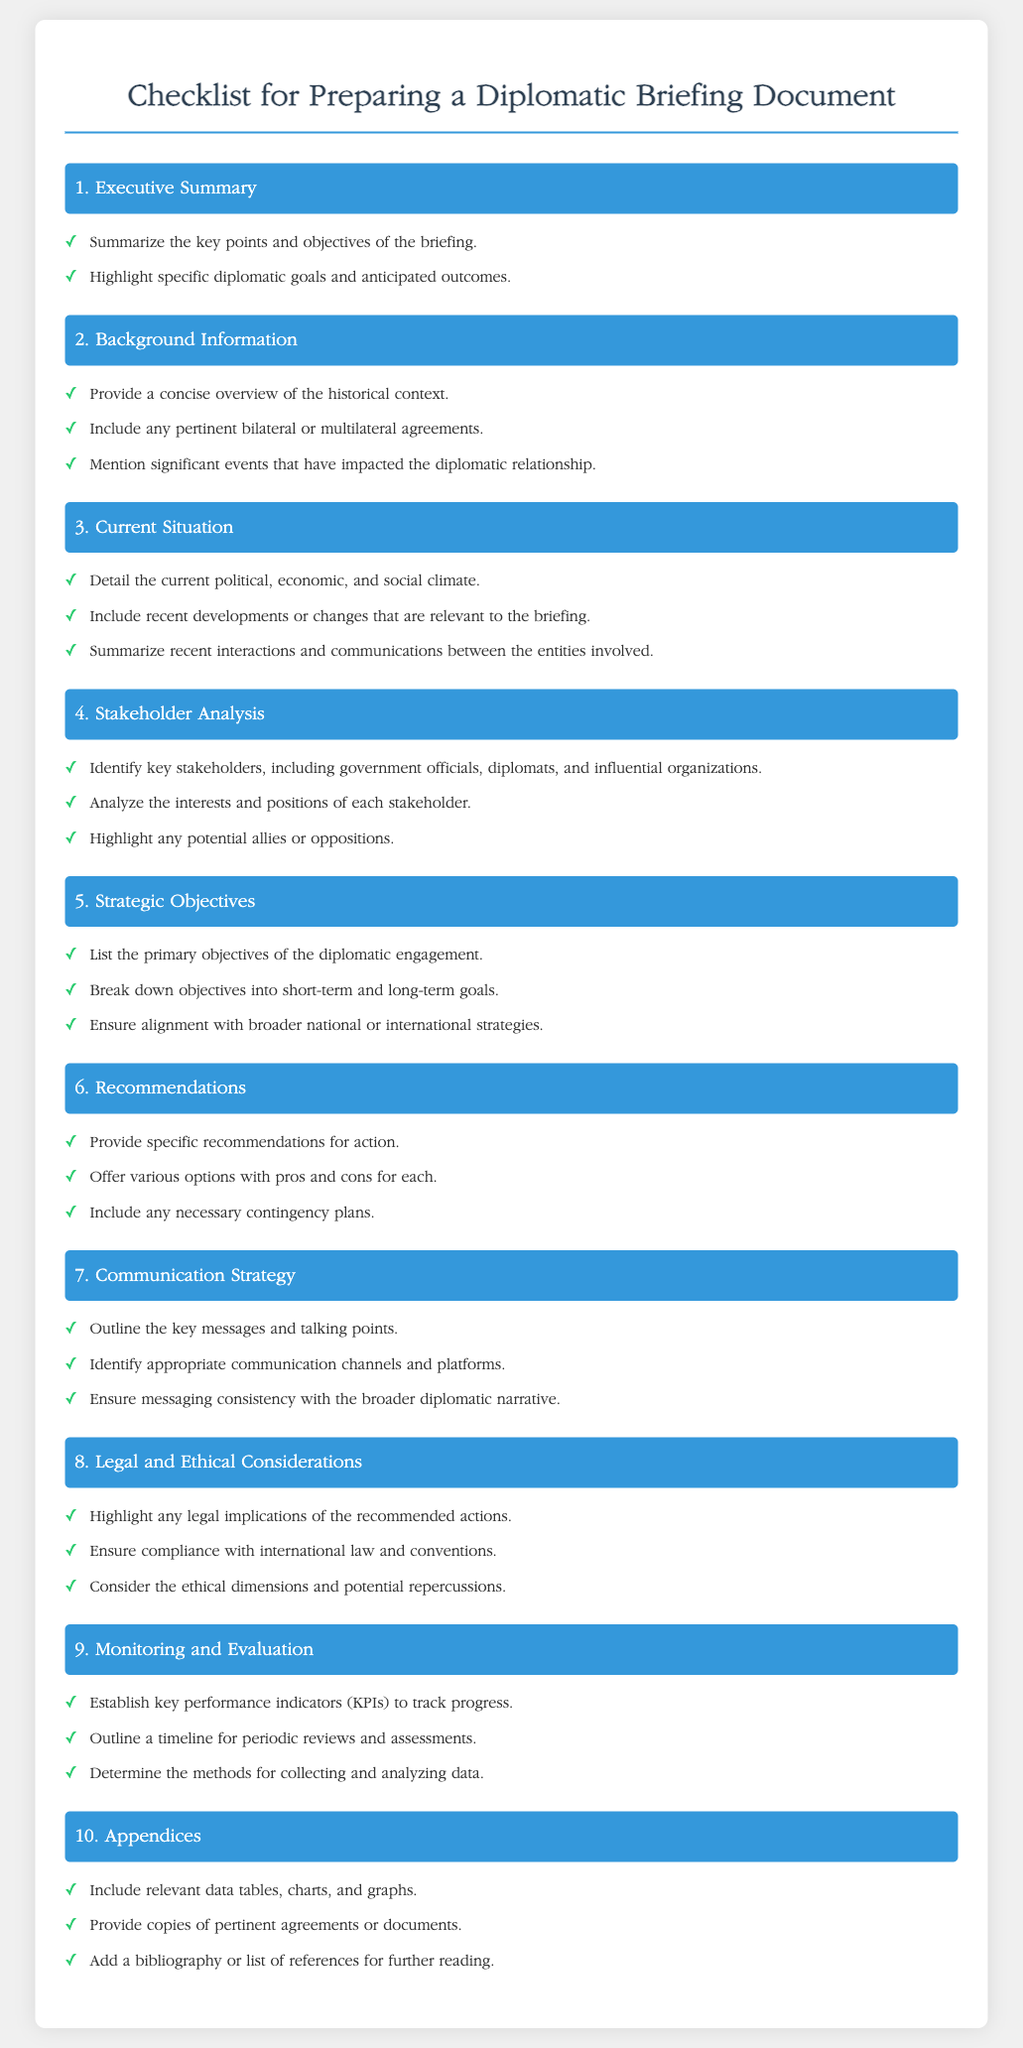What is the first section title? The first section is titled "Executive Summary," which outlines the key points and objectives of the briefing.
Answer: Executive Summary How many main sections are there in the checklist? The checklist consists of ten distinct sections, covering various aspects of preparing a diplomatic briefing document.
Answer: 10 What should be included in the stakeholder analysis? The stakeholder analysis should identify key stakeholders, analyze their interests and positions, and highlight potential allies or oppositions.
Answer: Key stakeholders and their interests What is the purpose of the recommendations section? The recommendations section provides specific actions, offers pros and cons of various options, and includes contingency plans.
Answer: Specific recommendations for action Which section addresses legal implications? The section titled "Legal and Ethical Considerations" highlights any legal implications of the recommended actions and compliance with international law.
Answer: Legal and Ethical Considerations What key component is associated with monitoring and evaluation? The monitoring and evaluation section includes establishing key performance indicators to track progress over time.
Answer: Key performance indicators What type of data should be included in the appendices? The appendices should include relevant data tables, charts, graphs, and copies of pertinent agreements or documents.
Answer: Relevant data tables, charts, and graphs What does the communication strategy outline? The communication strategy outlines the key messages and talking points, as well as appropriate communication channels.
Answer: Key messages and talking points 